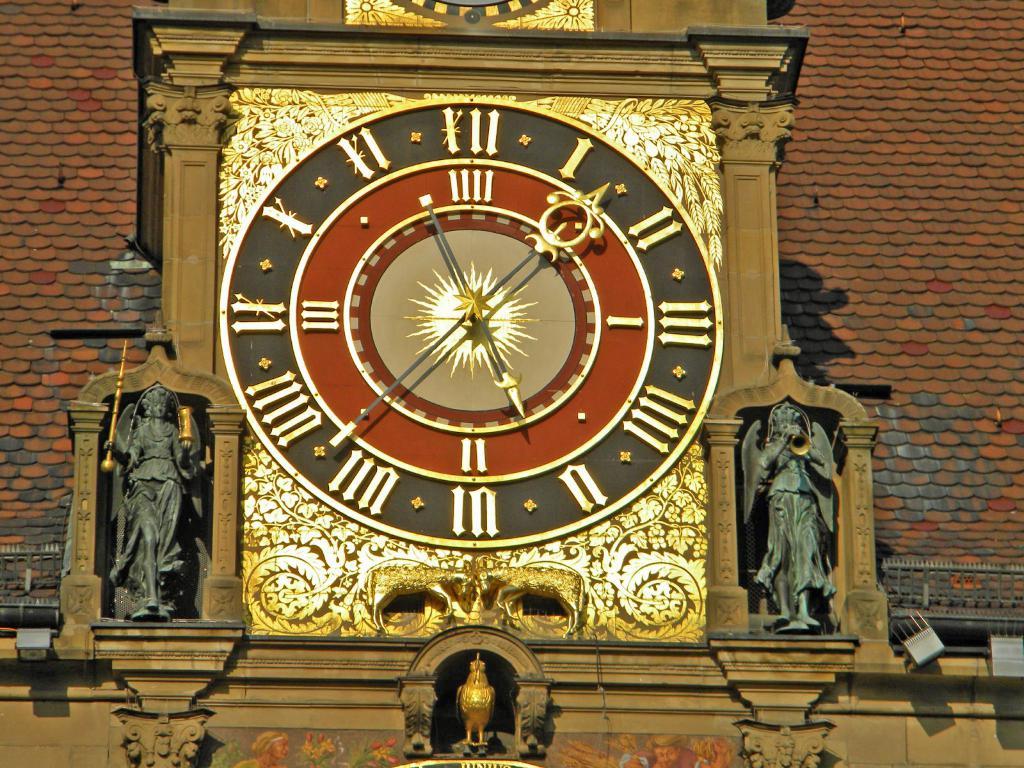What time to the nearest hour is displayed on this clock?
Make the answer very short. 5. 